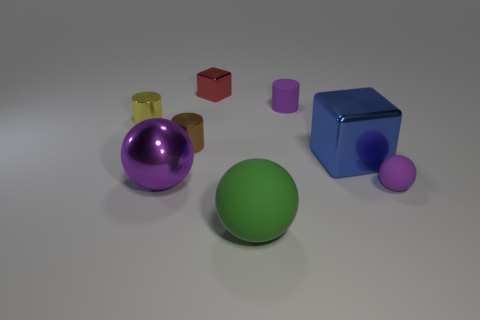There is a small cylinder that is the same color as the big metallic sphere; what is it made of?
Provide a short and direct response. Rubber. Are there any green spheres that have the same material as the large blue thing?
Provide a short and direct response. No. Is the big shiny sphere the same color as the small rubber sphere?
Make the answer very short. Yes. What material is the tiny object that is on the right side of the brown thing and in front of the small purple cylinder?
Give a very brief answer. Rubber. What is the color of the tiny cube?
Your answer should be compact. Red. How many tiny purple rubber things have the same shape as the large blue shiny thing?
Your response must be concise. 0. Is the cylinder in front of the yellow metal cylinder made of the same material as the tiny object that is on the right side of the blue block?
Your answer should be compact. No. There is a blue block that is behind the big thing that is left of the green ball; what is its size?
Your response must be concise. Large. What is the material of the tiny purple object that is the same shape as the brown metal object?
Your answer should be very brief. Rubber. Does the tiny purple rubber object in front of the purple rubber cylinder have the same shape as the large metal thing that is to the left of the big blue cube?
Make the answer very short. Yes. 